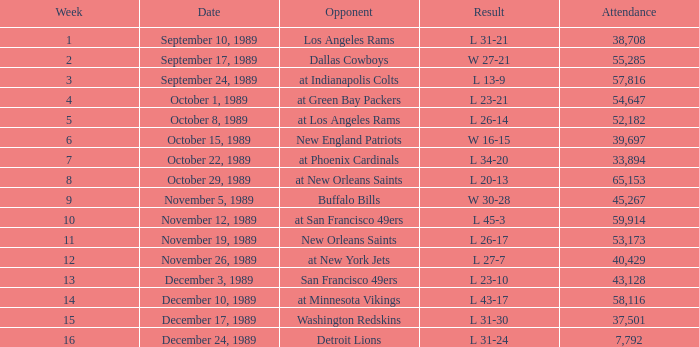Could you parse the entire table? {'header': ['Week', 'Date', 'Opponent', 'Result', 'Attendance'], 'rows': [['1', 'September 10, 1989', 'Los Angeles Rams', 'L 31-21', '38,708'], ['2', 'September 17, 1989', 'Dallas Cowboys', 'W 27-21', '55,285'], ['3', 'September 24, 1989', 'at Indianapolis Colts', 'L 13-9', '57,816'], ['4', 'October 1, 1989', 'at Green Bay Packers', 'L 23-21', '54,647'], ['5', 'October 8, 1989', 'at Los Angeles Rams', 'L 26-14', '52,182'], ['6', 'October 15, 1989', 'New England Patriots', 'W 16-15', '39,697'], ['7', 'October 22, 1989', 'at Phoenix Cardinals', 'L 34-20', '33,894'], ['8', 'October 29, 1989', 'at New Orleans Saints', 'L 20-13', '65,153'], ['9', 'November 5, 1989', 'Buffalo Bills', 'W 30-28', '45,267'], ['10', 'November 12, 1989', 'at San Francisco 49ers', 'L 45-3', '59,914'], ['11', 'November 19, 1989', 'New Orleans Saints', 'L 26-17', '53,173'], ['12', 'November 26, 1989', 'at New York Jets', 'L 27-7', '40,429'], ['13', 'December 3, 1989', 'San Francisco 49ers', 'L 23-10', '43,128'], ['14', 'December 10, 1989', 'at Minnesota Vikings', 'L 43-17', '58,116'], ['15', 'December 17, 1989', 'Washington Redskins', 'L 31-30', '37,501'], ['16', 'December 24, 1989', 'Detroit Lions', 'L 31-24', '7,792']]} For what week was the attendance 40,429? 12.0. 